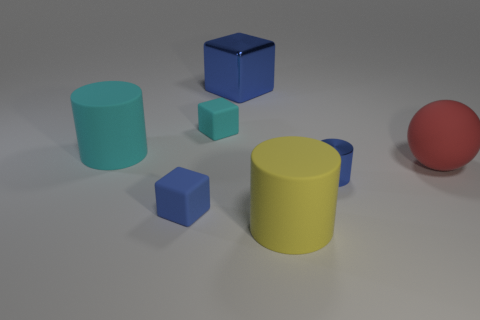Are there fewer large matte objects that are left of the blue cylinder than small blue metallic cylinders that are to the right of the red ball?
Provide a short and direct response. No. Are there more tiny metallic blocks than red things?
Offer a terse response. No. What material is the large yellow thing?
Your response must be concise. Rubber. The big matte cylinder that is to the left of the large yellow object is what color?
Keep it short and to the point. Cyan. Are there more big blocks in front of the big red thing than small blue shiny objects that are left of the small blue metal cylinder?
Keep it short and to the point. No. There is a blue cube that is behind the blue block left of the tiny matte cube behind the cyan matte cylinder; what size is it?
Ensure brevity in your answer.  Large. Is there a small shiny ball of the same color as the big cube?
Give a very brief answer. No. What number of blue metallic things are there?
Your answer should be compact. 2. What is the small blue thing that is behind the tiny matte cube that is in front of the rubber cylinder that is behind the blue matte thing made of?
Provide a succinct answer. Metal. Are there any tiny purple objects made of the same material as the large yellow thing?
Provide a short and direct response. No. 